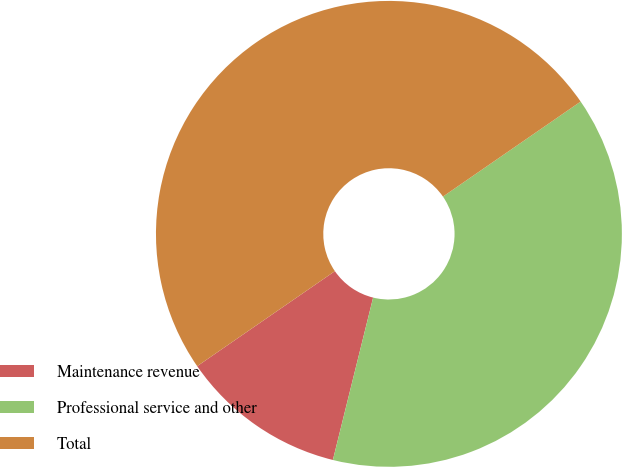Convert chart. <chart><loc_0><loc_0><loc_500><loc_500><pie_chart><fcel>Maintenance revenue<fcel>Professional service and other<fcel>Total<nl><fcel>11.52%<fcel>38.48%<fcel>50.0%<nl></chart> 